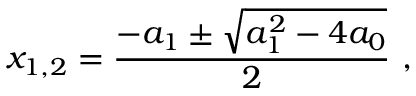<formula> <loc_0><loc_0><loc_500><loc_500>x _ { 1 , 2 } = \frac { - a _ { 1 } \pm \sqrt { a _ { 1 } ^ { 2 } - 4 a _ { 0 } } } { 2 } ,</formula> 